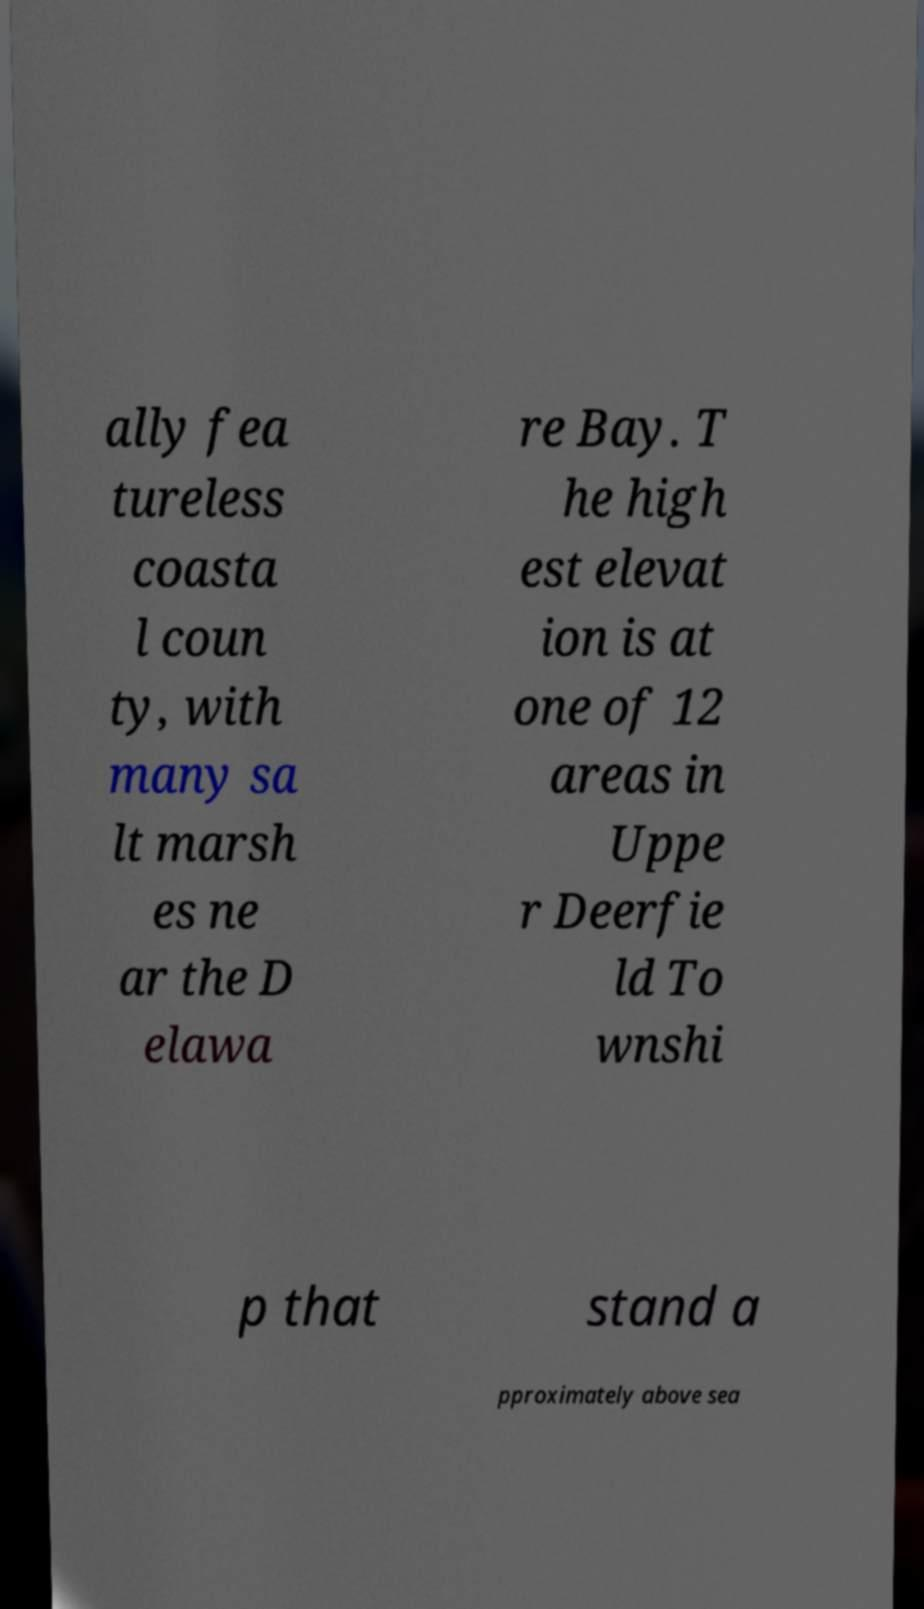What messages or text are displayed in this image? I need them in a readable, typed format. ally fea tureless coasta l coun ty, with many sa lt marsh es ne ar the D elawa re Bay. T he high est elevat ion is at one of 12 areas in Uppe r Deerfie ld To wnshi p that stand a pproximately above sea 